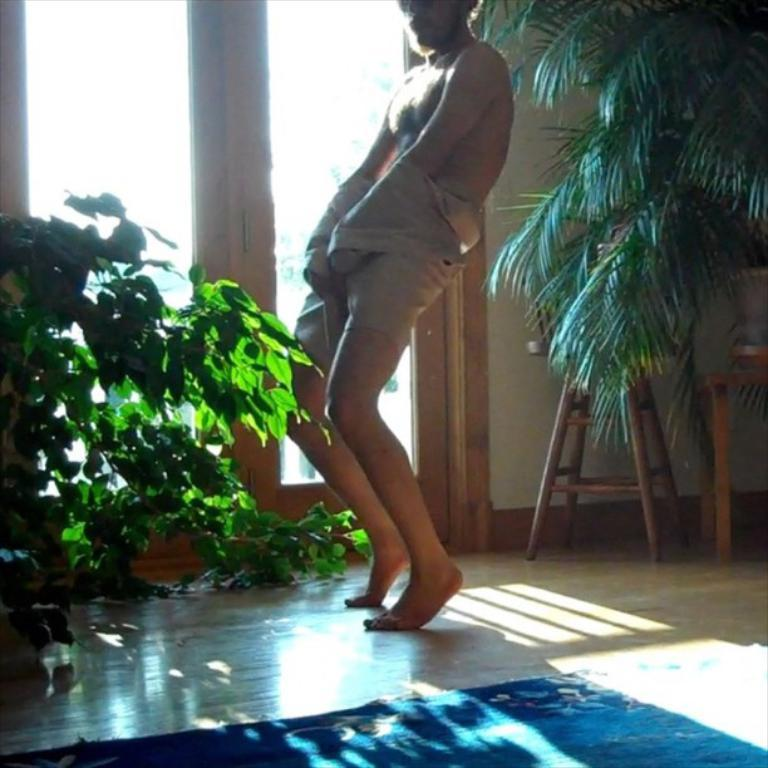What type of surface is the person standing on in the image? The person is standing on a wooden floor. What can be seen on the floor near the person? There is a mat in the image. What type of vegetation is present in the image? There are plants in the image. What type of furniture is visible in the image? There is a wooden stool and a table in the image. What is visible in the background of the image? There are glass doors in the background of the image. What type of chicken is sitting on the table in the image? There is no chicken present in the image; it only features a person, a mat, plants, a wooden stool, a table, and glass doors. What type of poison is visible on the wooden stool in the image? There is no poison present in the image; it only features a person, a mat, plants, a wooden stool, a table, and glass doors. 